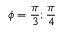<formula> <loc_0><loc_0><loc_500><loc_500>\phi = \frac { \pi } { 3 } ; \frac { \pi } { 4 }</formula> 